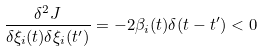Convert formula to latex. <formula><loc_0><loc_0><loc_500><loc_500>\frac { \delta ^ { 2 } J } { \delta \xi _ { i } ( t ) \delta \xi _ { i } ( t ^ { \prime } ) } = - 2 \beta _ { i } ( t ) \delta ( t - t ^ { \prime } ) < 0</formula> 